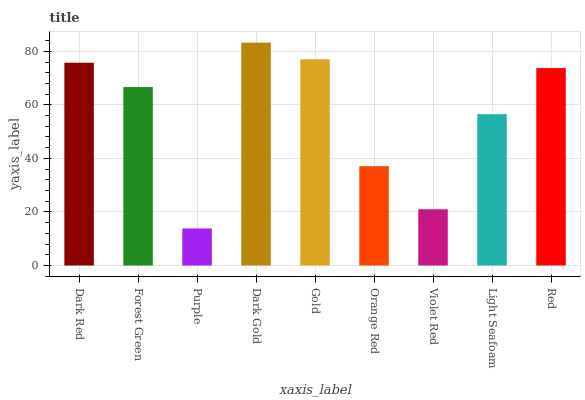Is Purple the minimum?
Answer yes or no. Yes. Is Dark Gold the maximum?
Answer yes or no. Yes. Is Forest Green the minimum?
Answer yes or no. No. Is Forest Green the maximum?
Answer yes or no. No. Is Dark Red greater than Forest Green?
Answer yes or no. Yes. Is Forest Green less than Dark Red?
Answer yes or no. Yes. Is Forest Green greater than Dark Red?
Answer yes or no. No. Is Dark Red less than Forest Green?
Answer yes or no. No. Is Forest Green the high median?
Answer yes or no. Yes. Is Forest Green the low median?
Answer yes or no. Yes. Is Gold the high median?
Answer yes or no. No. Is Red the low median?
Answer yes or no. No. 